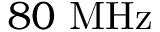<formula> <loc_0><loc_0><loc_500><loc_500>8 0 M H z</formula> 